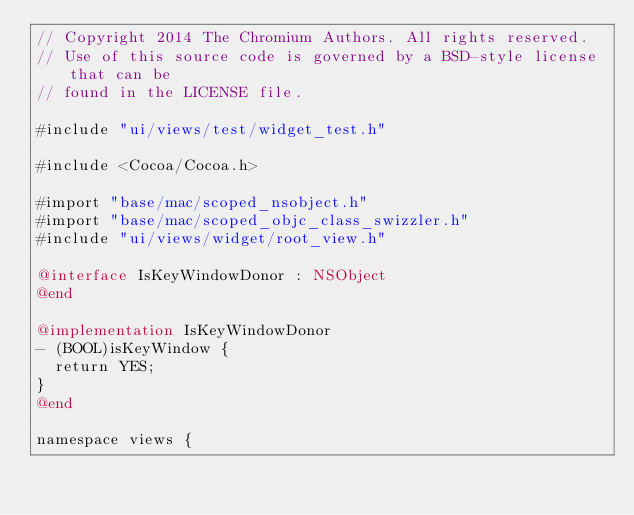Convert code to text. <code><loc_0><loc_0><loc_500><loc_500><_ObjectiveC_>// Copyright 2014 The Chromium Authors. All rights reserved.
// Use of this source code is governed by a BSD-style license that can be
// found in the LICENSE file.

#include "ui/views/test/widget_test.h"

#include <Cocoa/Cocoa.h>

#import "base/mac/scoped_nsobject.h"
#import "base/mac/scoped_objc_class_swizzler.h"
#include "ui/views/widget/root_view.h"

@interface IsKeyWindowDonor : NSObject
@end

@implementation IsKeyWindowDonor
- (BOOL)isKeyWindow {
  return YES;
}
@end

namespace views {</code> 